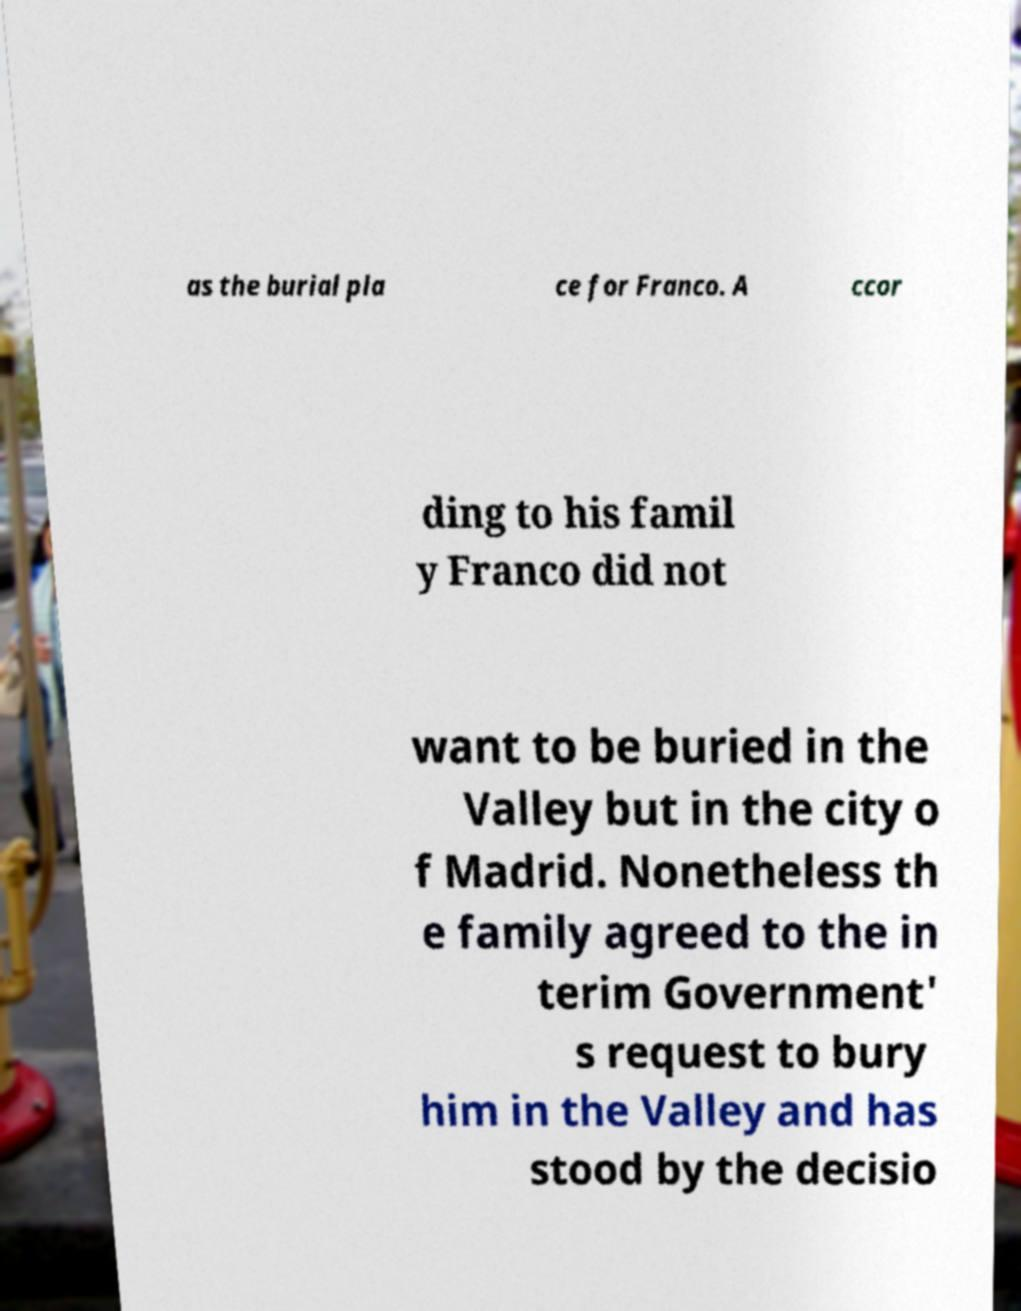Please identify and transcribe the text found in this image. as the burial pla ce for Franco. A ccor ding to his famil y Franco did not want to be buried in the Valley but in the city o f Madrid. Nonetheless th e family agreed to the in terim Government' s request to bury him in the Valley and has stood by the decisio 